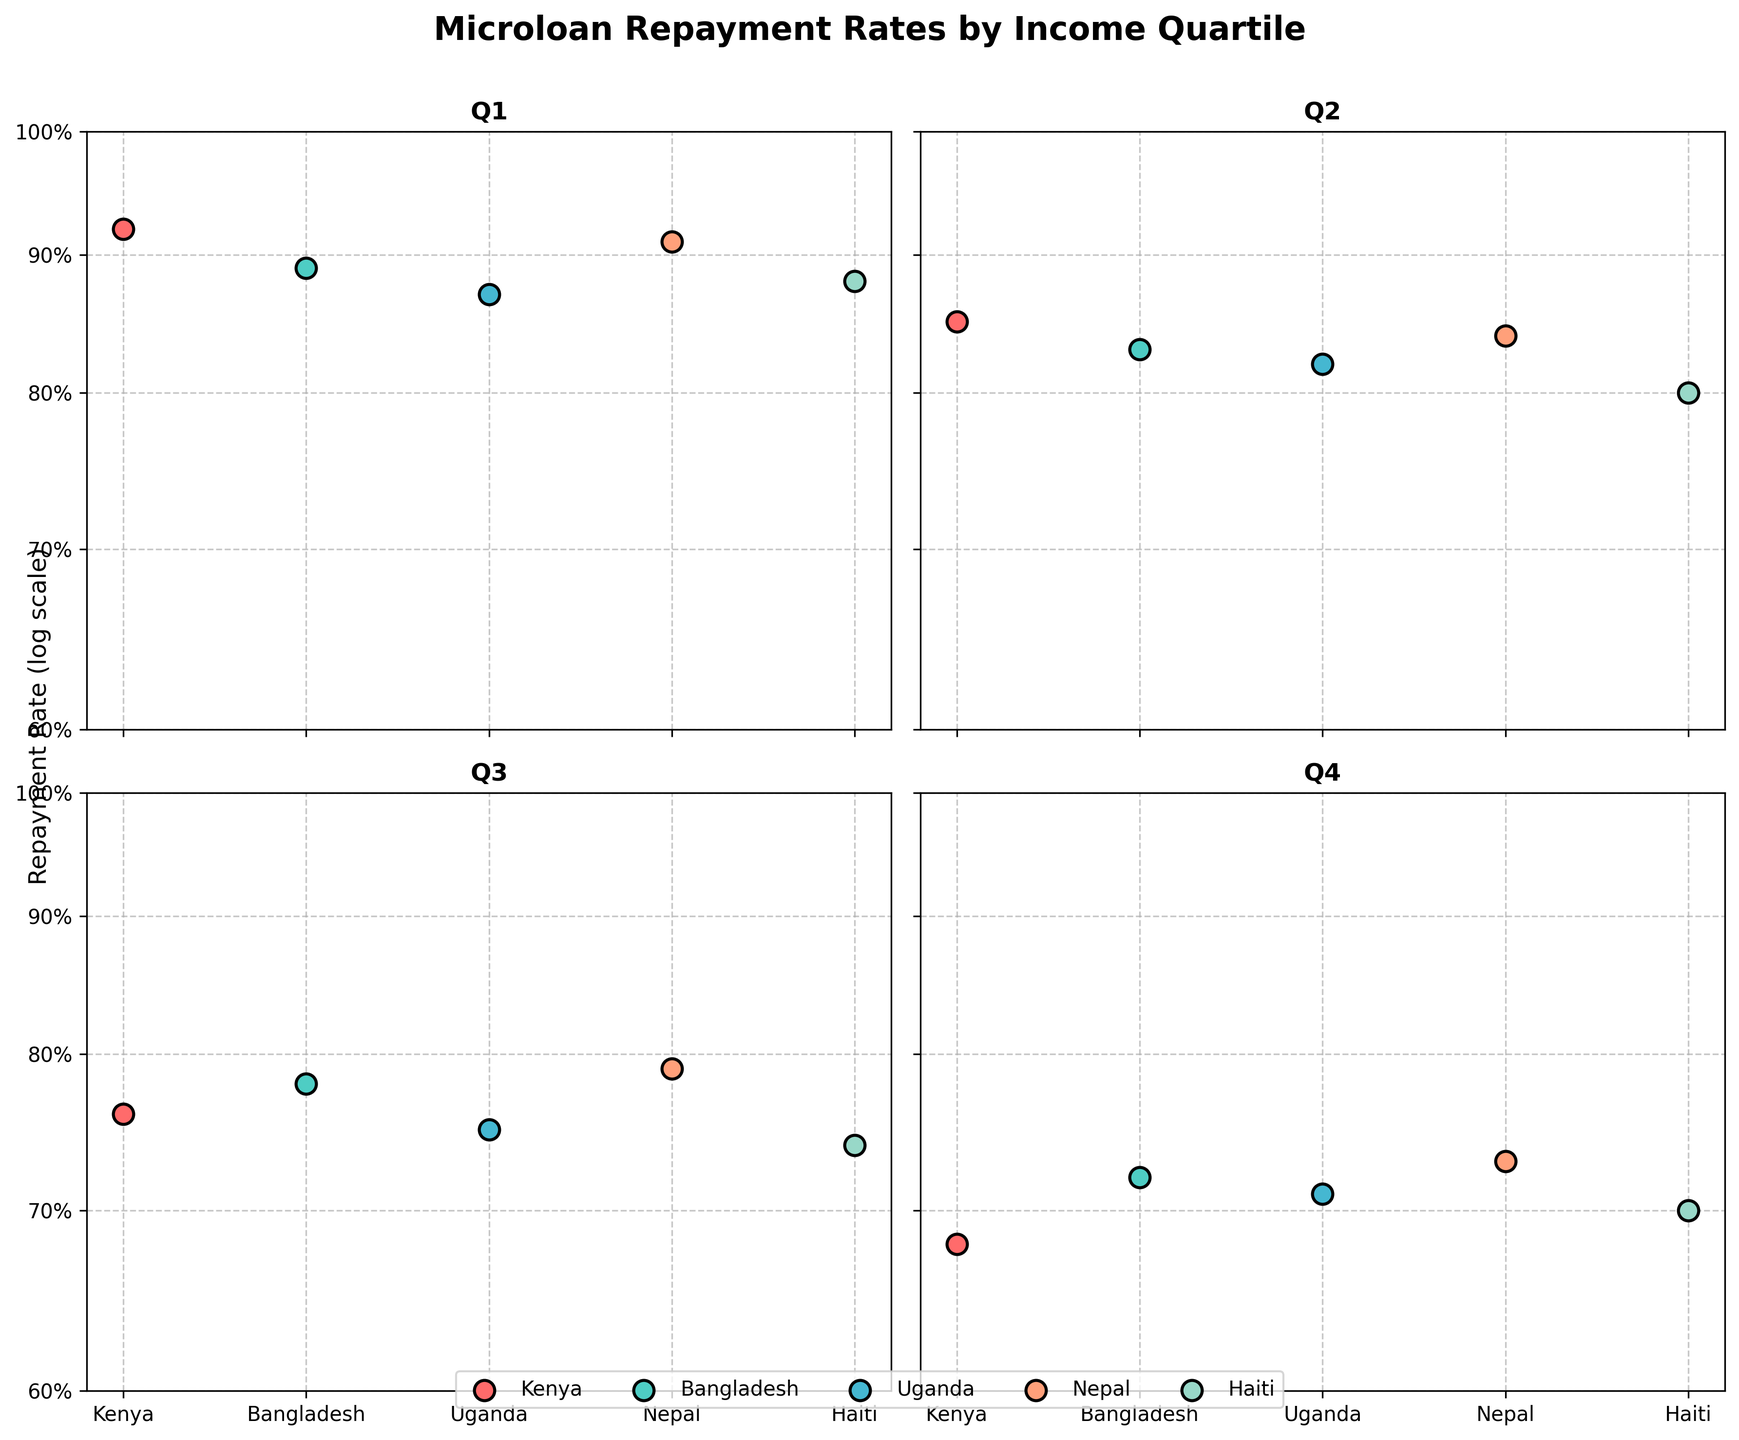What is the title of the figure? The title is displayed at the top center of the figure. The title reads "Microloan Repayment Rates by Income Quartile".
Answer: Microloan Repayment Rates by Income Quartile Which country has the highest repayment rate in Quartile 1 (Q1)? Quartile 1 (Q1) subplots show the repayment rates across different countries. Among them, Kenya has the highest repayment rate of 0.92.
Answer: Kenya How many different income quartiles are represented in the figure? The figure has subplots for each income quartile. There are four distinct subplots, labeled as Q1, Q2, Q3, and Q4, respectively.
Answer: Four Which country has the lowest repayment rate in Quartile 4 (Q4)? Quartile 4 (Q4) subplot shows the repayment rates for different countries, and Haiti has the lowest repayment rate of 0.70.
Answer: Haiti Compare the repayment rates of Uganda between Quartile 2 (Q2) and Quartile 3 (Q3). Which one is lower? By observing the subplots for Q2 and Q3, Uganda's repayment rate in Q2 is 0.82 and in Q3 is 0.75. The Q3 repayment rate is lower.
Answer: Q3 What is the overall trend in repayment rates as the income quartiles increase from Q1 to Q4? Analyzing all the subplots, the repayment rates decrease as the income quartiles increase from Q1 to Q4.
Answer: Decrease What are the y-axis labels in the figure? The y-axis is labeled as "Repayment Rate (log scale)" and the tick marks show percentages: 60%, 70%, 80%, 90%, and 100%.
Answer: Repayment Rate (log scale); 60%, 70%, 80%, 90%, 100% Which two countries have closer repayment rates in Quartile 3 (Q3)? In the Q3 subplot, Kenya has a rate of 0.76 and Uganda has a rate of 0.75, making their repayment rates closest among the countries.
Answer: Kenya and Uganda List the countries in Quartile 2 (Q2) with their repayment rates from highest to lowest. By observing the Q2 subplot, the repayment rates from highest to lowest are: Nepal (0.84), Kenya (0.85), Bangladesh (0.83), Uganda (0.82), Haiti (0.80).
Answer: Nepal (0.84), Kenya (0.85), Bangladesh (0.83), Uganda (0.82), Haiti (0.80) 